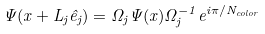<formula> <loc_0><loc_0><loc_500><loc_500>\Psi ( x + L _ { j } \hat { e } _ { j } ) = \Omega _ { j } \Psi ( x ) \Omega _ { j } ^ { - 1 } e ^ { i \pi / N _ { c o l o r } }</formula> 